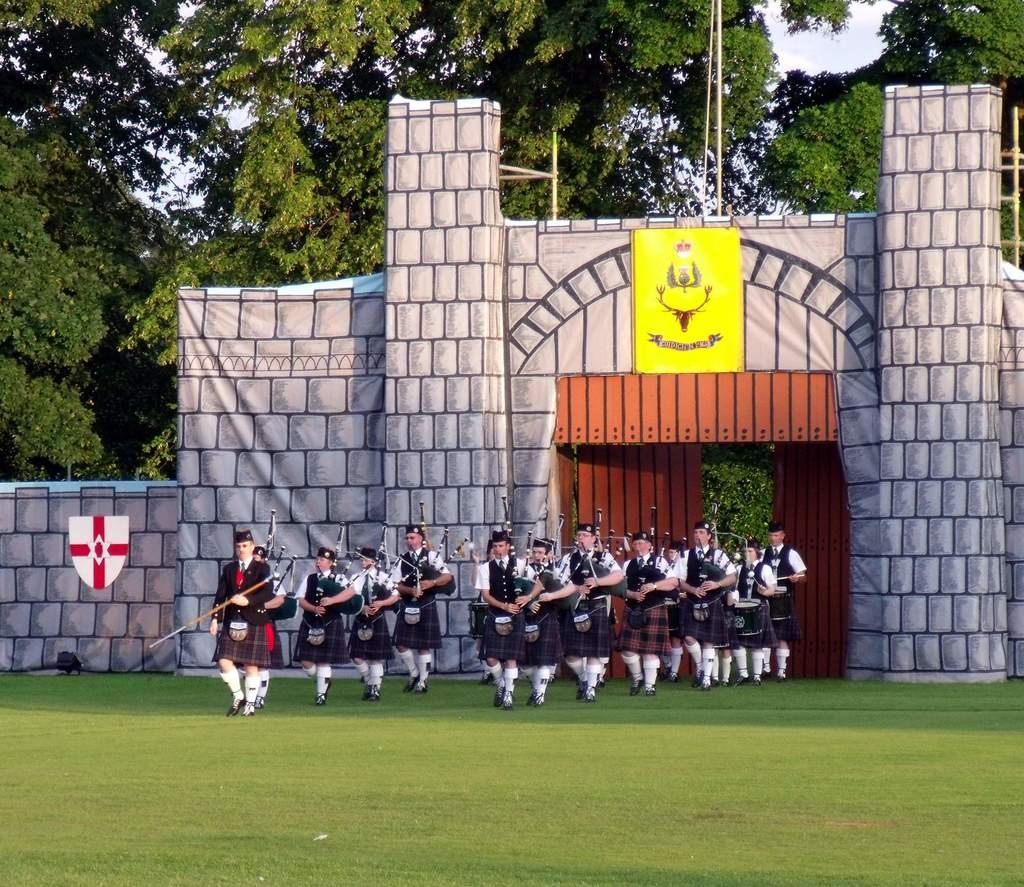What is happening with the group of people in the image? The people in the image are walking on the grass. What are the people holding in the image? The people are holding objects. What can be seen in the background of the image? There are trees and the sky visible in the background of the image. What architectural feature is visible in the image? There are doors visible in the image. How many boats can be seen sailing in the sky in the image? There are no boats visible in the image, let alone sailing in the sky. What type of flight is the group of people taking in the image? The image does not depict any flight or air travel; the people are walking on the grass. 